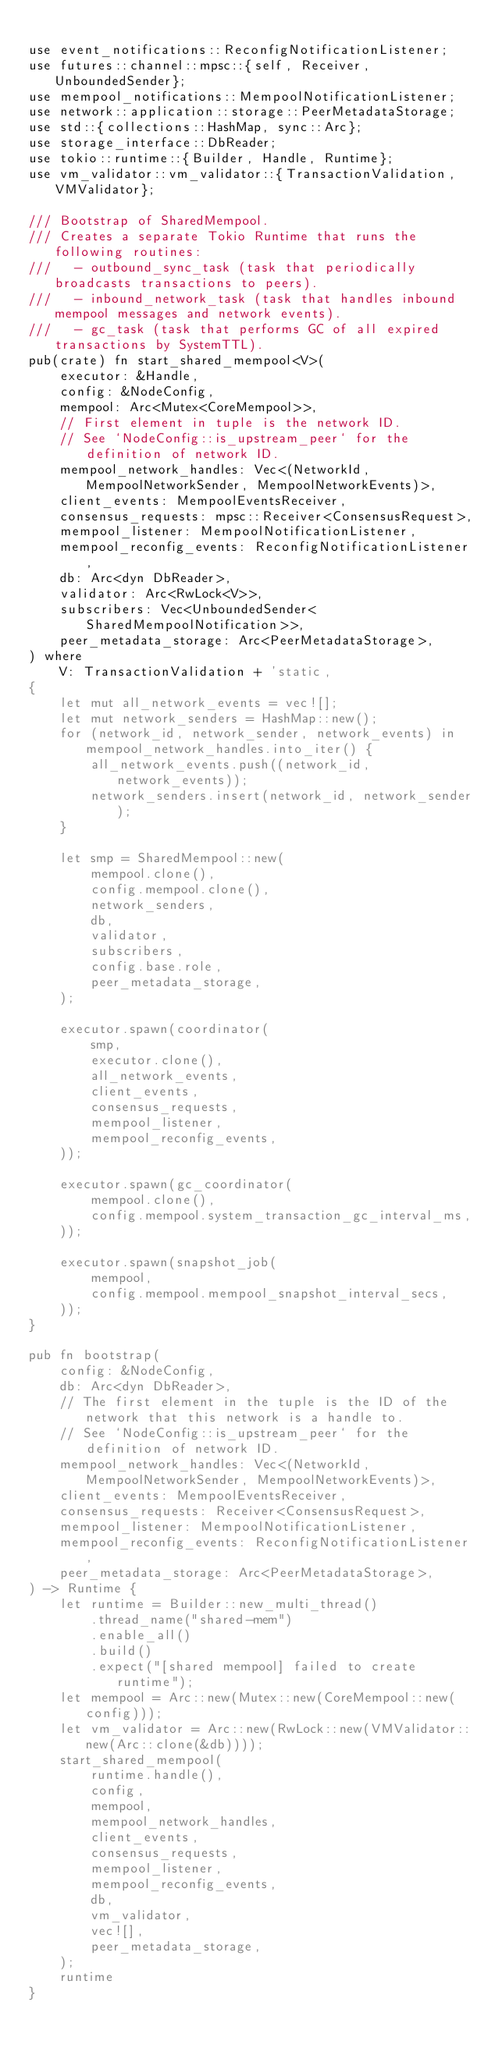<code> <loc_0><loc_0><loc_500><loc_500><_Rust_>
use event_notifications::ReconfigNotificationListener;
use futures::channel::mpsc::{self, Receiver, UnboundedSender};
use mempool_notifications::MempoolNotificationListener;
use network::application::storage::PeerMetadataStorage;
use std::{collections::HashMap, sync::Arc};
use storage_interface::DbReader;
use tokio::runtime::{Builder, Handle, Runtime};
use vm_validator::vm_validator::{TransactionValidation, VMValidator};

/// Bootstrap of SharedMempool.
/// Creates a separate Tokio Runtime that runs the following routines:
///   - outbound_sync_task (task that periodically broadcasts transactions to peers).
///   - inbound_network_task (task that handles inbound mempool messages and network events).
///   - gc_task (task that performs GC of all expired transactions by SystemTTL).
pub(crate) fn start_shared_mempool<V>(
    executor: &Handle,
    config: &NodeConfig,
    mempool: Arc<Mutex<CoreMempool>>,
    // First element in tuple is the network ID.
    // See `NodeConfig::is_upstream_peer` for the definition of network ID.
    mempool_network_handles: Vec<(NetworkId, MempoolNetworkSender, MempoolNetworkEvents)>,
    client_events: MempoolEventsReceiver,
    consensus_requests: mpsc::Receiver<ConsensusRequest>,
    mempool_listener: MempoolNotificationListener,
    mempool_reconfig_events: ReconfigNotificationListener,
    db: Arc<dyn DbReader>,
    validator: Arc<RwLock<V>>,
    subscribers: Vec<UnboundedSender<SharedMempoolNotification>>,
    peer_metadata_storage: Arc<PeerMetadataStorage>,
) where
    V: TransactionValidation + 'static,
{
    let mut all_network_events = vec![];
    let mut network_senders = HashMap::new();
    for (network_id, network_sender, network_events) in mempool_network_handles.into_iter() {
        all_network_events.push((network_id, network_events));
        network_senders.insert(network_id, network_sender);
    }

    let smp = SharedMempool::new(
        mempool.clone(),
        config.mempool.clone(),
        network_senders,
        db,
        validator,
        subscribers,
        config.base.role,
        peer_metadata_storage,
    );

    executor.spawn(coordinator(
        smp,
        executor.clone(),
        all_network_events,
        client_events,
        consensus_requests,
        mempool_listener,
        mempool_reconfig_events,
    ));

    executor.spawn(gc_coordinator(
        mempool.clone(),
        config.mempool.system_transaction_gc_interval_ms,
    ));

    executor.spawn(snapshot_job(
        mempool,
        config.mempool.mempool_snapshot_interval_secs,
    ));
}

pub fn bootstrap(
    config: &NodeConfig,
    db: Arc<dyn DbReader>,
    // The first element in the tuple is the ID of the network that this network is a handle to.
    // See `NodeConfig::is_upstream_peer` for the definition of network ID.
    mempool_network_handles: Vec<(NetworkId, MempoolNetworkSender, MempoolNetworkEvents)>,
    client_events: MempoolEventsReceiver,
    consensus_requests: Receiver<ConsensusRequest>,
    mempool_listener: MempoolNotificationListener,
    mempool_reconfig_events: ReconfigNotificationListener,
    peer_metadata_storage: Arc<PeerMetadataStorage>,
) -> Runtime {
    let runtime = Builder::new_multi_thread()
        .thread_name("shared-mem")
        .enable_all()
        .build()
        .expect("[shared mempool] failed to create runtime");
    let mempool = Arc::new(Mutex::new(CoreMempool::new(config)));
    let vm_validator = Arc::new(RwLock::new(VMValidator::new(Arc::clone(&db))));
    start_shared_mempool(
        runtime.handle(),
        config,
        mempool,
        mempool_network_handles,
        client_events,
        consensus_requests,
        mempool_listener,
        mempool_reconfig_events,
        db,
        vm_validator,
        vec![],
        peer_metadata_storage,
    );
    runtime
}
</code> 